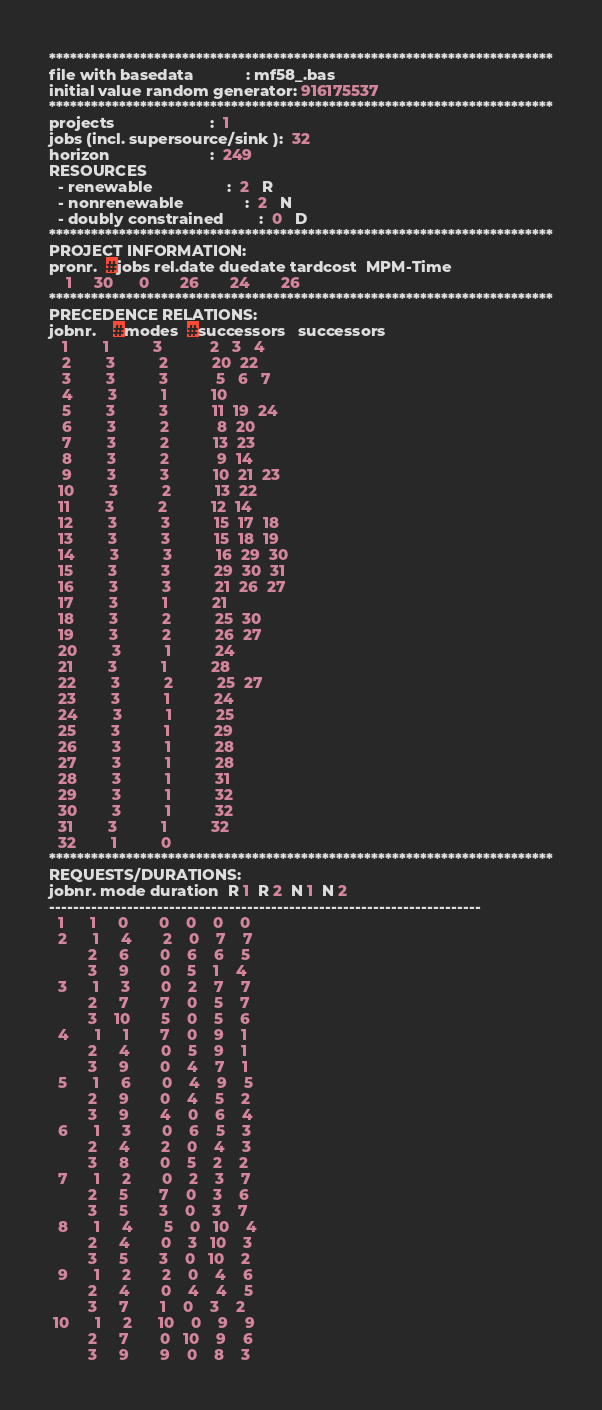Convert code to text. <code><loc_0><loc_0><loc_500><loc_500><_ObjectiveC_>************************************************************************
file with basedata            : mf58_.bas
initial value random generator: 916175537
************************************************************************
projects                      :  1
jobs (incl. supersource/sink ):  32
horizon                       :  249
RESOURCES
  - renewable                 :  2   R
  - nonrenewable              :  2   N
  - doubly constrained        :  0   D
************************************************************************
PROJECT INFORMATION:
pronr.  #jobs rel.date duedate tardcost  MPM-Time
    1     30      0       26       24       26
************************************************************************
PRECEDENCE RELATIONS:
jobnr.    #modes  #successors   successors
   1        1          3           2   3   4
   2        3          2          20  22
   3        3          3           5   6   7
   4        3          1          10
   5        3          3          11  19  24
   6        3          2           8  20
   7        3          2          13  23
   8        3          2           9  14
   9        3          3          10  21  23
  10        3          2          13  22
  11        3          2          12  14
  12        3          3          15  17  18
  13        3          3          15  18  19
  14        3          3          16  29  30
  15        3          3          29  30  31
  16        3          3          21  26  27
  17        3          1          21
  18        3          2          25  30
  19        3          2          26  27
  20        3          1          24
  21        3          1          28
  22        3          2          25  27
  23        3          1          24
  24        3          1          25
  25        3          1          29
  26        3          1          28
  27        3          1          28
  28        3          1          31
  29        3          1          32
  30        3          1          32
  31        3          1          32
  32        1          0        
************************************************************************
REQUESTS/DURATIONS:
jobnr. mode duration  R 1  R 2  N 1  N 2
------------------------------------------------------------------------
  1      1     0       0    0    0    0
  2      1     4       2    0    7    7
         2     6       0    6    6    5
         3     9       0    5    1    4
  3      1     3       0    2    7    7
         2     7       7    0    5    7
         3    10       5    0    5    6
  4      1     1       7    0    9    1
         2     4       0    5    9    1
         3     9       0    4    7    1
  5      1     6       0    4    9    5
         2     9       0    4    5    2
         3     9       4    0    6    4
  6      1     3       0    6    5    3
         2     4       2    0    4    3
         3     8       0    5    2    2
  7      1     2       0    2    3    7
         2     5       7    0    3    6
         3     5       3    0    3    7
  8      1     4       5    0   10    4
         2     4       0    3   10    3
         3     5       3    0   10    2
  9      1     2       2    0    4    6
         2     4       0    4    4    5
         3     7       1    0    3    2
 10      1     2      10    0    9    9
         2     7       0   10    9    6
         3     9       9    0    8    3</code> 